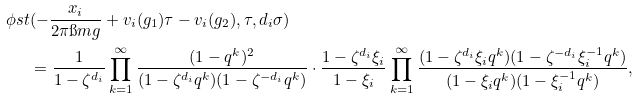Convert formula to latex. <formula><loc_0><loc_0><loc_500><loc_500>\phi s t & ( - \frac { x _ { i } } { 2 \pi \i m g } + v _ { i } ( g _ { 1 } ) \tau - v _ { i } ( g _ { 2 } ) , \tau , d _ { i } \sigma ) \\ & = \frac { 1 } { 1 - \zeta ^ { d _ { i } } } \prod _ { k = 1 } ^ { \infty } \frac { ( 1 - q ^ { k } ) ^ { 2 } } { ( 1 - \zeta ^ { d _ { i } } q ^ { k } ) ( 1 - \zeta ^ { - d _ { i } } q ^ { k } ) } \cdot \frac { 1 - \zeta ^ { d _ { i } } \xi _ { i } } { 1 - \xi _ { i } } \prod _ { k = 1 } ^ { \infty } \frac { ( 1 - \zeta ^ { d _ { i } } \xi _ { i } q ^ { k } ) ( 1 - \zeta ^ { - d _ { i } } \xi _ { i } ^ { - 1 } q ^ { k } ) } { ( 1 - \xi _ { i } q ^ { k } ) ( 1 - \xi _ { i } ^ { - 1 } q ^ { k } ) } ,</formula> 